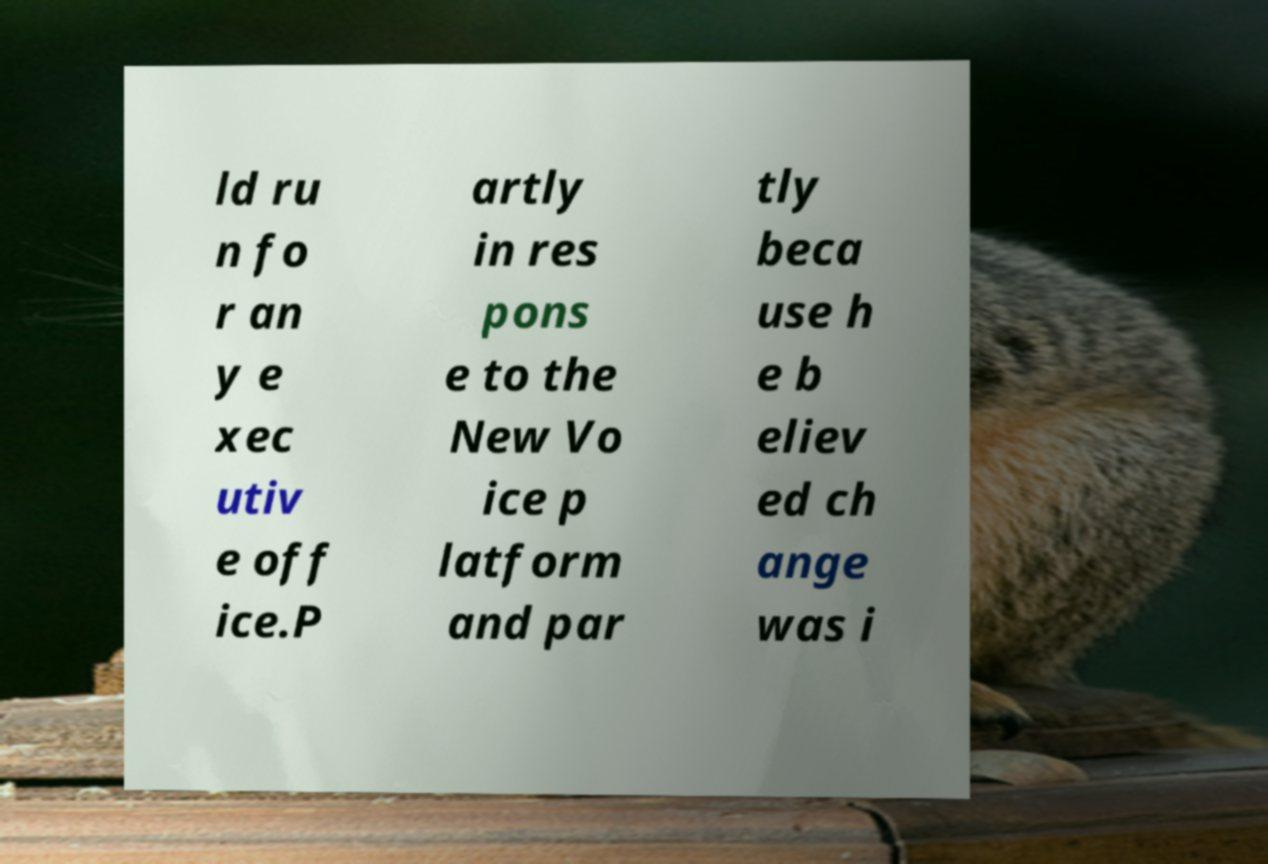What messages or text are displayed in this image? I need them in a readable, typed format. ld ru n fo r an y e xec utiv e off ice.P artly in res pons e to the New Vo ice p latform and par tly beca use h e b eliev ed ch ange was i 